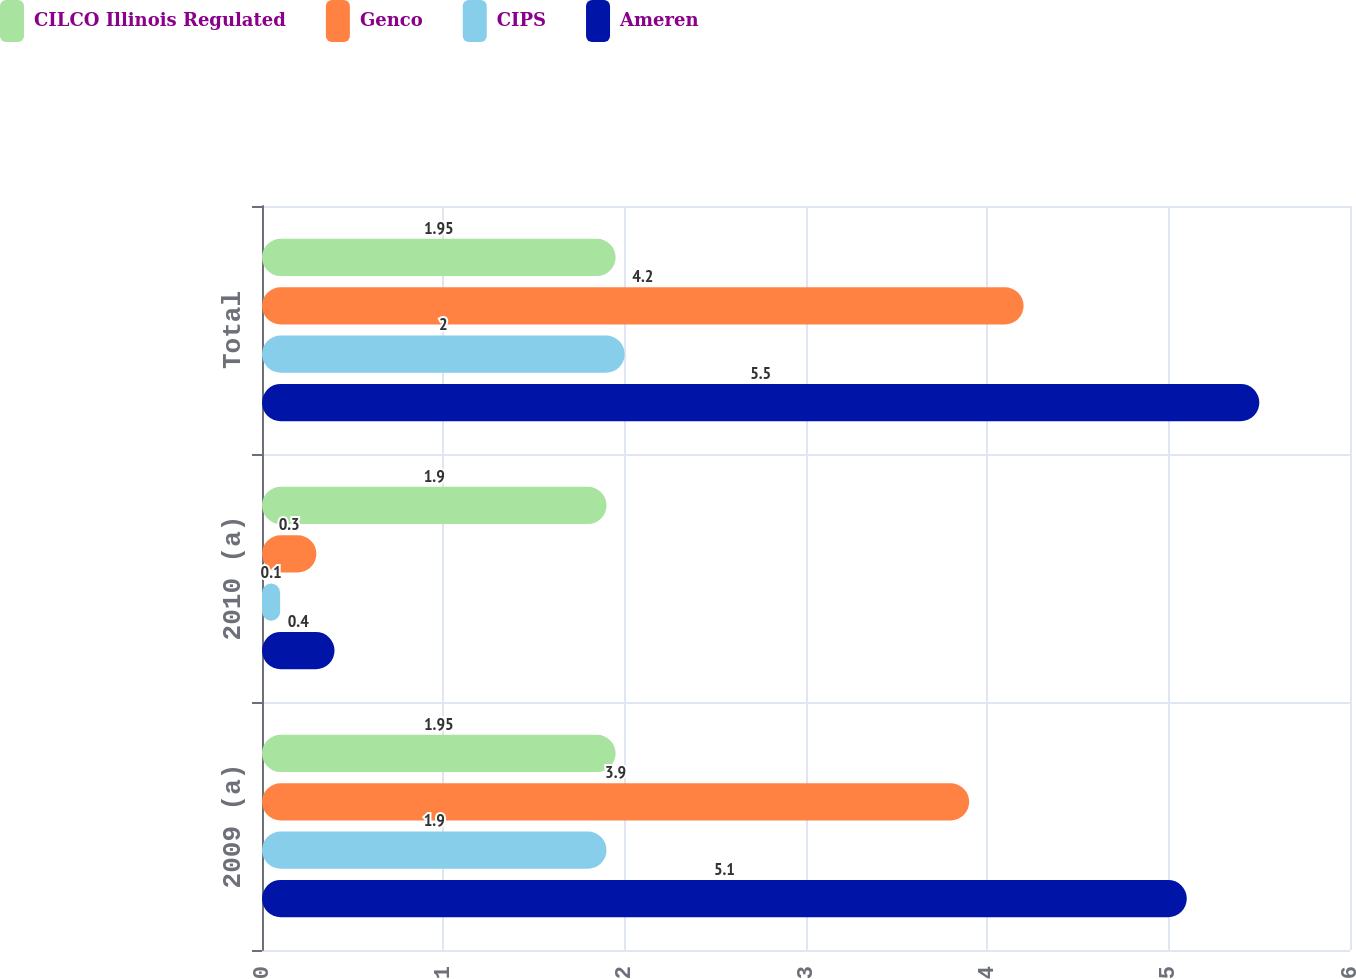Convert chart. <chart><loc_0><loc_0><loc_500><loc_500><stacked_bar_chart><ecel><fcel>2009 (a)<fcel>2010 (a)<fcel>Total<nl><fcel>CILCO Illinois Regulated<fcel>1.95<fcel>1.9<fcel>1.95<nl><fcel>Genco<fcel>3.9<fcel>0.3<fcel>4.2<nl><fcel>CIPS<fcel>1.9<fcel>0.1<fcel>2<nl><fcel>Ameren<fcel>5.1<fcel>0.4<fcel>5.5<nl></chart> 